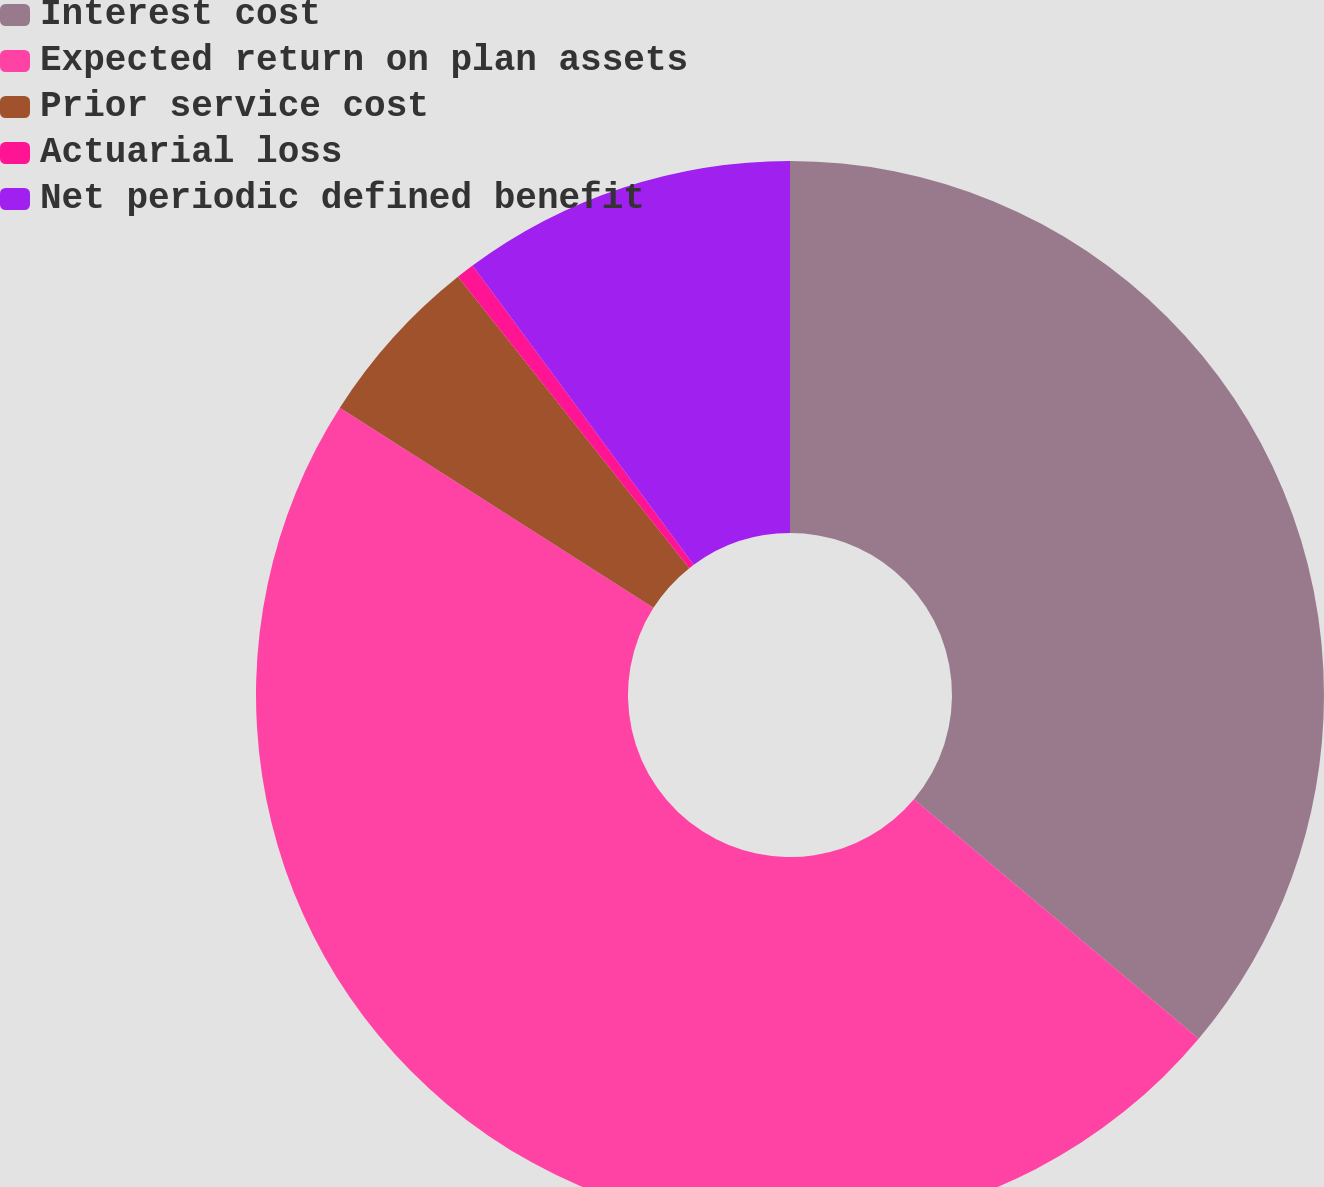Convert chart to OTSL. <chart><loc_0><loc_0><loc_500><loc_500><pie_chart><fcel>Interest cost<fcel>Expected return on plan assets<fcel>Prior service cost<fcel>Actuarial loss<fcel>Net periodic defined benefit<nl><fcel>36.13%<fcel>47.91%<fcel>5.28%<fcel>0.55%<fcel>10.13%<nl></chart> 